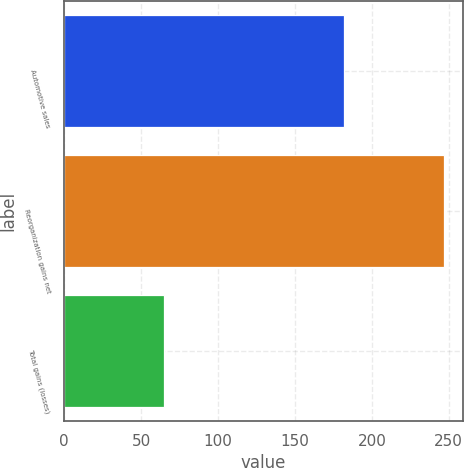Convert chart to OTSL. <chart><loc_0><loc_0><loc_500><loc_500><bar_chart><fcel>Automotive sales<fcel>Reorganization gains net<fcel>Total gains (losses)<nl><fcel>182<fcel>247<fcel>65<nl></chart> 